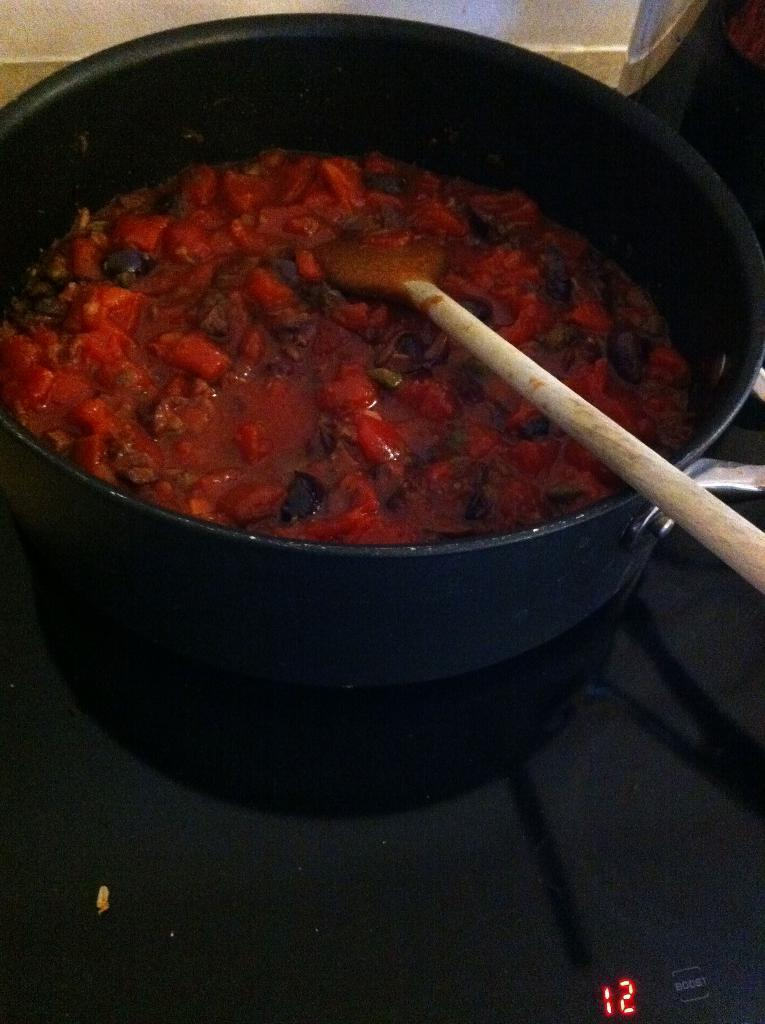What is located in the image that can be used for mixing or serving food? There is a spatula in the image that can be used for mixing or serving food. What is the main container for food in the image? There is a bowl in the image that can hold food. What is the surface on which the food is placed in the image? There is a platform in the image on which the food is placed in the image. What type of information is displayed at the bottom of the image? Digital numbers are visible at the bottom of the image. What type of bell can be heard ringing in the image? There is no bell present in the image, and therefore no sound can be heard. What type of quartz is visible in the image? There is no quartz present in the image. 